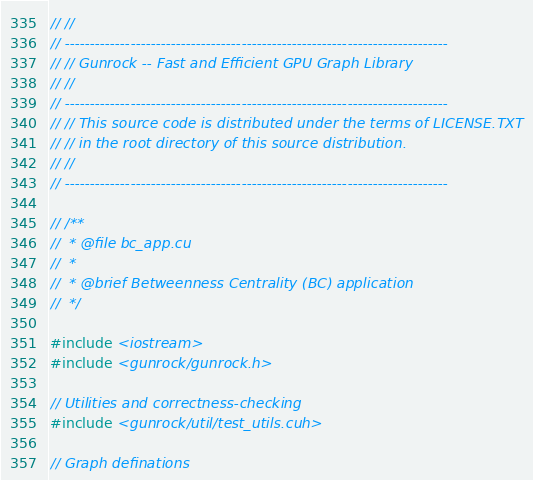<code> <loc_0><loc_0><loc_500><loc_500><_Cuda_>// //
// ----------------------------------------------------------------------------
// // Gunrock -- Fast and Efficient GPU Graph Library
// //
// ----------------------------------------------------------------------------
// // This source code is distributed under the terms of LICENSE.TXT
// // in the root directory of this source distribution.
// //
// ----------------------------------------------------------------------------

// /**
//  * @file bc_app.cu
//  *
//  * @brief Betweenness Centrality (BC) application
//  */

#include <iostream>
#include <gunrock/gunrock.h>

// Utilities and correctness-checking
#include <gunrock/util/test_utils.cuh>

// Graph definations</code> 